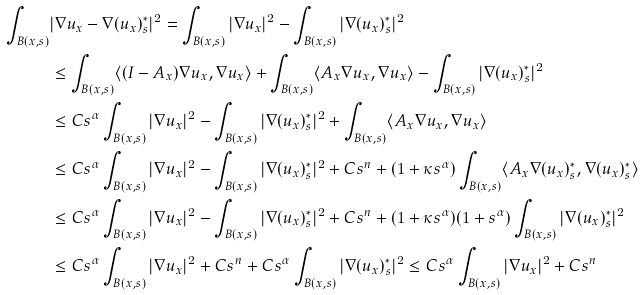<formula> <loc_0><loc_0><loc_500><loc_500>\int _ { B ( x , s ) } & | \nabla u _ { x } - \nabla ( u _ { x } ) _ { s } ^ { * } | ^ { 2 } = \int _ { B ( x , s ) } | \nabla u _ { x } | ^ { 2 } - \int _ { B ( x , s ) } | \nabla ( u _ { x } ) _ { s } ^ { * } | ^ { 2 } \\ & \leq \int _ { B ( x , s ) } \langle ( I - A _ { x } ) \nabla u _ { x } , \nabla u _ { x } \rangle + \int _ { B ( x , s ) } \langle A _ { x } \nabla u _ { x } , \nabla u _ { x } \rangle - \int _ { B ( x , s ) } | \nabla ( u _ { x } ) _ { s } ^ { * } | ^ { 2 } \\ & \leq C s ^ { \alpha } \int _ { B ( x , s ) } | \nabla u _ { x } | ^ { 2 } - \int _ { B ( x , s ) } | \nabla ( u _ { x } ) _ { s } ^ { * } | ^ { 2 } + \int _ { B ( x , s ) } \langle A _ { x } \nabla u _ { x } , \nabla u _ { x } \rangle \\ & \leq C s ^ { \alpha } \int _ { B ( x , s ) } | \nabla u _ { x } | ^ { 2 } - \int _ { B ( x , s ) } | \nabla ( u _ { x } ) _ { s } ^ { * } | ^ { 2 } + C s ^ { n } + ( 1 + \kappa s ^ { \alpha } ) \int _ { B ( x , s ) } \langle A _ { x } \nabla ( u _ { x } ) _ { s } ^ { * } , \nabla ( u _ { x } ) _ { s } ^ { * } \rangle \\ & \leq C s ^ { \alpha } \int _ { B ( x , s ) } | \nabla u _ { x } | ^ { 2 } - \int _ { B ( x , s ) } | \nabla ( u _ { x } ) _ { s } ^ { * } | ^ { 2 } + C s ^ { n } + ( 1 + \kappa s ^ { \alpha } ) ( 1 + s ^ { \alpha } ) \int _ { B ( x , s ) } | \nabla ( u _ { x } ) _ { s } ^ { * } | ^ { 2 } \\ & \leq C s ^ { \alpha } \int _ { B ( x , s ) } | \nabla u _ { x } | ^ { 2 } + C s ^ { n } + C s ^ { \alpha } \int _ { B ( x , s ) } | \nabla ( u _ { x } ) _ { s } ^ { * } | ^ { 2 } \leq C s ^ { \alpha } \int _ { B ( x , s ) } | \nabla u _ { x } | ^ { 2 } + C s ^ { n } \\ &</formula> 